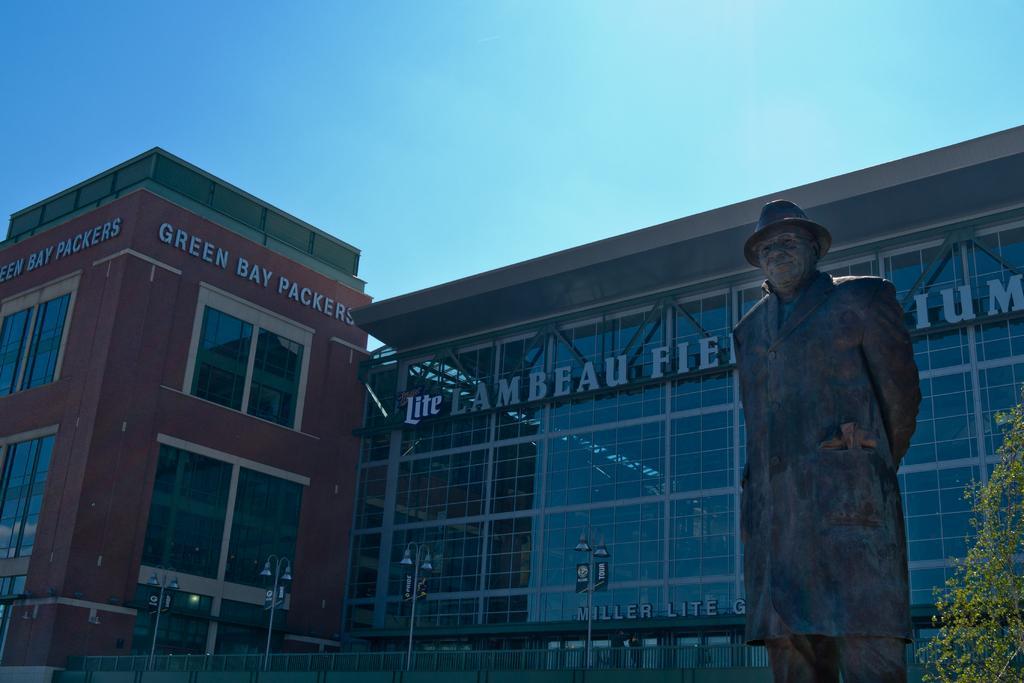Please provide a concise description of this image. There are two huge buildings and in front of the building there is a big sculpture of a man and behind the sculpture there is a fencing around the building and there are four pole lights inside the fencing and on the right side there is a tree. 